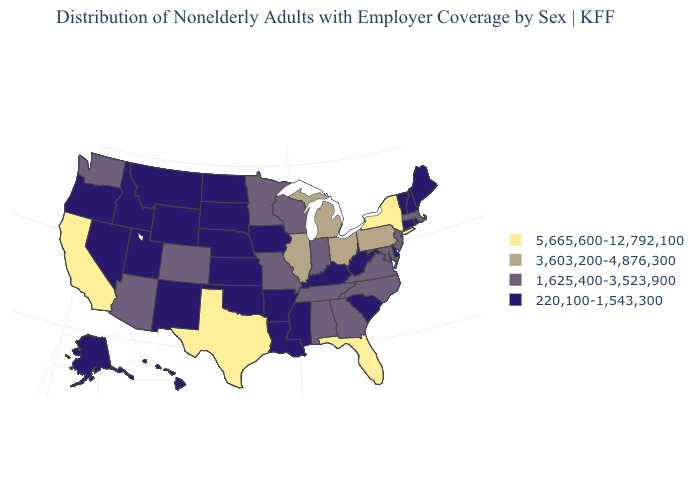What is the highest value in the MidWest ?
Answer briefly. 3,603,200-4,876,300. Is the legend a continuous bar?
Give a very brief answer. No. What is the lowest value in the West?
Answer briefly. 220,100-1,543,300. Name the states that have a value in the range 3,603,200-4,876,300?
Short answer required. Illinois, Michigan, Ohio, Pennsylvania. What is the value of Washington?
Short answer required. 1,625,400-3,523,900. Does West Virginia have the lowest value in the USA?
Answer briefly. Yes. Among the states that border Arizona , does New Mexico have the lowest value?
Write a very short answer. Yes. Which states have the lowest value in the South?
Be succinct. Arkansas, Delaware, Kentucky, Louisiana, Mississippi, Oklahoma, South Carolina, West Virginia. Name the states that have a value in the range 220,100-1,543,300?
Short answer required. Alaska, Arkansas, Connecticut, Delaware, Hawaii, Idaho, Iowa, Kansas, Kentucky, Louisiana, Maine, Mississippi, Montana, Nebraska, Nevada, New Hampshire, New Mexico, North Dakota, Oklahoma, Oregon, Rhode Island, South Carolina, South Dakota, Utah, Vermont, West Virginia, Wyoming. Does the first symbol in the legend represent the smallest category?
Concise answer only. No. Does New York have the lowest value in the USA?
Write a very short answer. No. Which states have the lowest value in the USA?
Quick response, please. Alaska, Arkansas, Connecticut, Delaware, Hawaii, Idaho, Iowa, Kansas, Kentucky, Louisiana, Maine, Mississippi, Montana, Nebraska, Nevada, New Hampshire, New Mexico, North Dakota, Oklahoma, Oregon, Rhode Island, South Carolina, South Dakota, Utah, Vermont, West Virginia, Wyoming. What is the value of Nebraska?
Concise answer only. 220,100-1,543,300. What is the value of California?
Give a very brief answer. 5,665,600-12,792,100. 